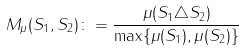<formula> <loc_0><loc_0><loc_500><loc_500>M _ { \mu } ( S _ { 1 } , S _ { 2 } ) \colon = \frac { \mu ( S _ { 1 } \triangle S _ { 2 } ) } { \max \{ \mu ( S _ { 1 } ) , \mu ( S _ { 2 } ) \} }</formula> 